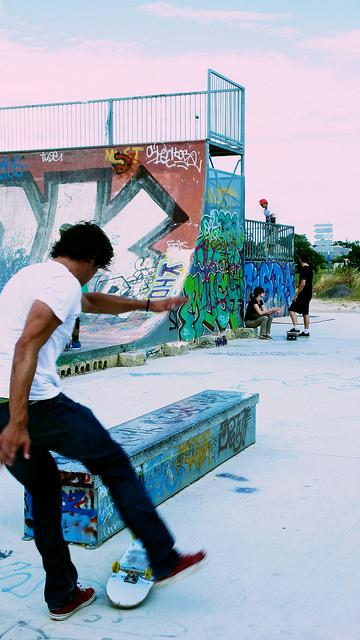What is the large ramp used for? Please explain your reasoning. skateboarding. The half-pipe style of this ramp and it's proximity to skateboarders tell us what it's used for. 